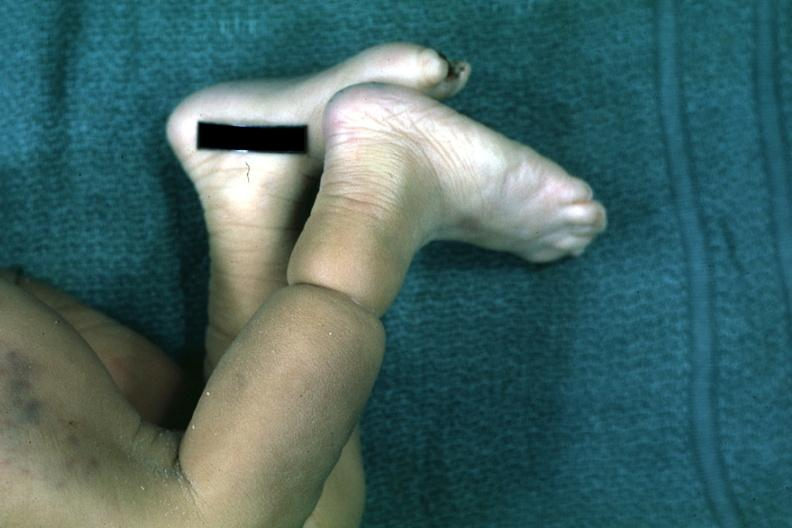re hours present?
Answer the question using a single word or phrase. No 